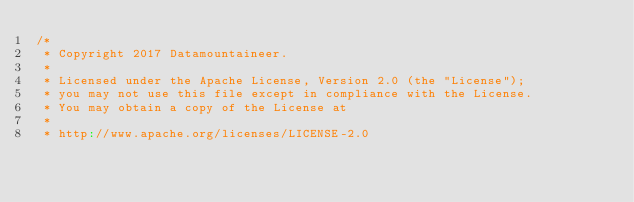Convert code to text. <code><loc_0><loc_0><loc_500><loc_500><_Scala_>/*
 * Copyright 2017 Datamountaineer.
 *
 * Licensed under the Apache License, Version 2.0 (the "License");
 * you may not use this file except in compliance with the License.
 * You may obtain a copy of the License at
 *
 * http://www.apache.org/licenses/LICENSE-2.0</code> 